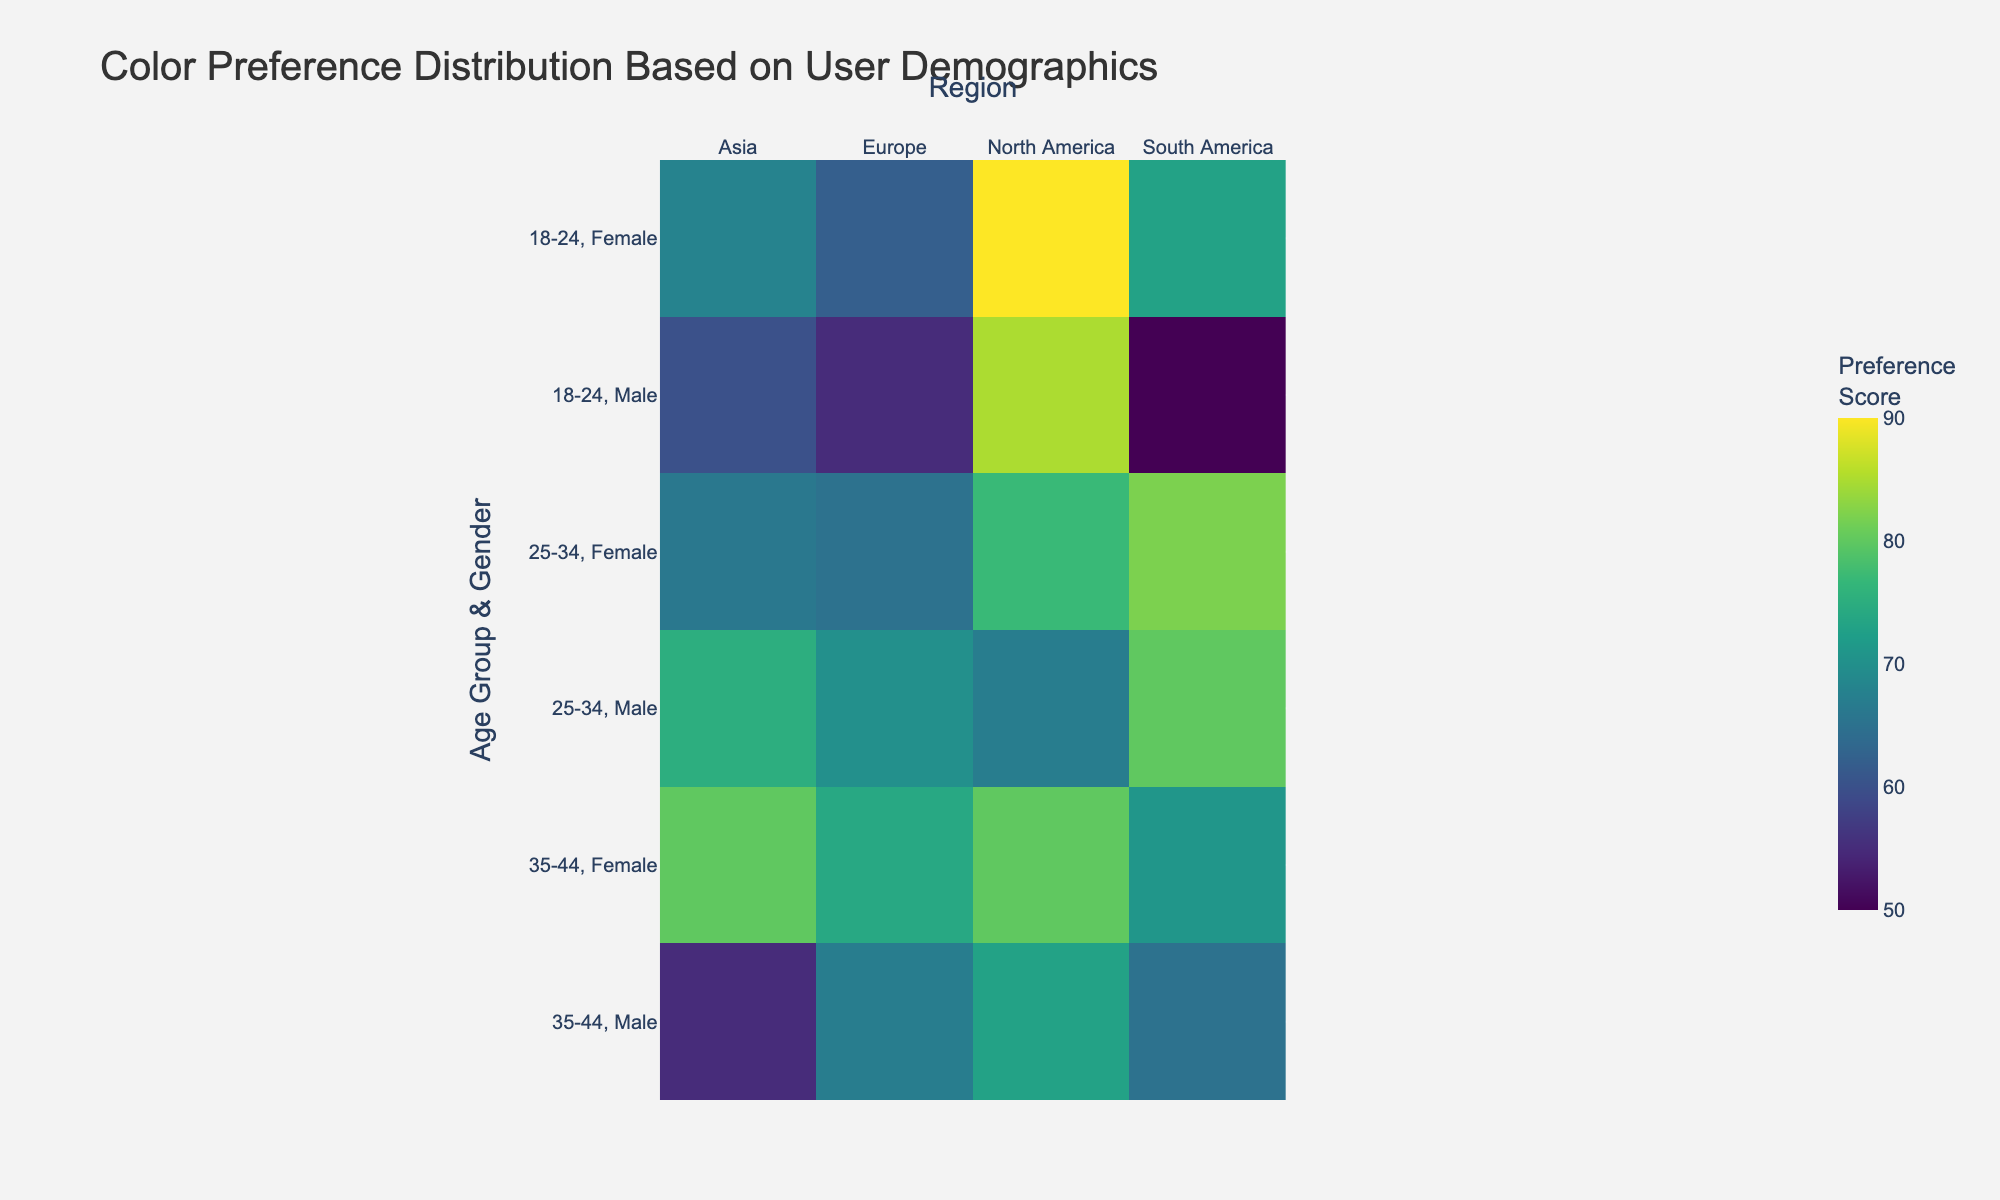How many age groups are represented in the heatmap? The heatmap shows the preference scores aggregated by age group and gender across different regions. From the y-axis labels, we see three different age groups represented: 18-24, 25-34, and 35-44.
Answer: 3 What is the highest preference score for females in North America? To answer this, we need to find the highest value from the 'Female' rows in the 'North America' column. In the heatmap, the highest preference score for females in North America is 90.
Answer: 90 Which gender and age group in Europe has the lowest average preference score? By examining the heatmap cells corresponding to Europe, we can find that "18-24, Male" in Europe has the lowest average preference score of 55.
Answer: 18-24, Male Compare the preference scores between "25-34, Female" in Asia and North America. Which one is higher? By looking at the heatmap, we see the preference score for "25-34, Female" in Asia is 66 and in North America is 77. Therefore, "25-34, Female" in North America has a higher score.
Answer: North America What is the difference in preference scores between "35-44, Male" in South America and Europe? The heatmap shows that "35-44, Male" in South America has a score of 65 while in Europe it is 67. Subtracting these gives 67 - 65 = 2.
Answer: 2 What color scale is used in the heatmap? The heatmap uses the 'Viridis' color scale to represent different preference scores. This can be inferred from the gradient of colors used in the cells.
Answer: Viridis Which age group and gender in North America has the second highest preference score? Examining the heatmap, the second highest preference score in North America is seen for "35-44, Female" with a score of 80.
Answer: 35-44, Female Between "18-24, Female" and "35-44, Female" across all regions, who has higher average preference scores? Calculating the average for both groups: 
- 18-24 Female: (90 + 62 + 68 + 73)/4 = 73.25 
- 35-44 Female: (80 + 74 + 80 + 71)/4 = 76.25 
Thus, "35-44, Female" has a higher average score.
Answer: 35-44, Female 